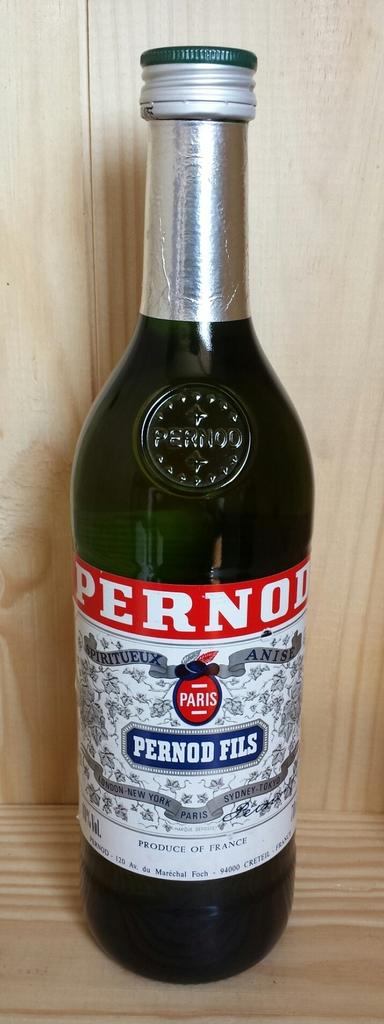Where was this beverage made?
Provide a succinct answer. France. What is the brand name of the beer?
Provide a short and direct response. Pernod fils. 